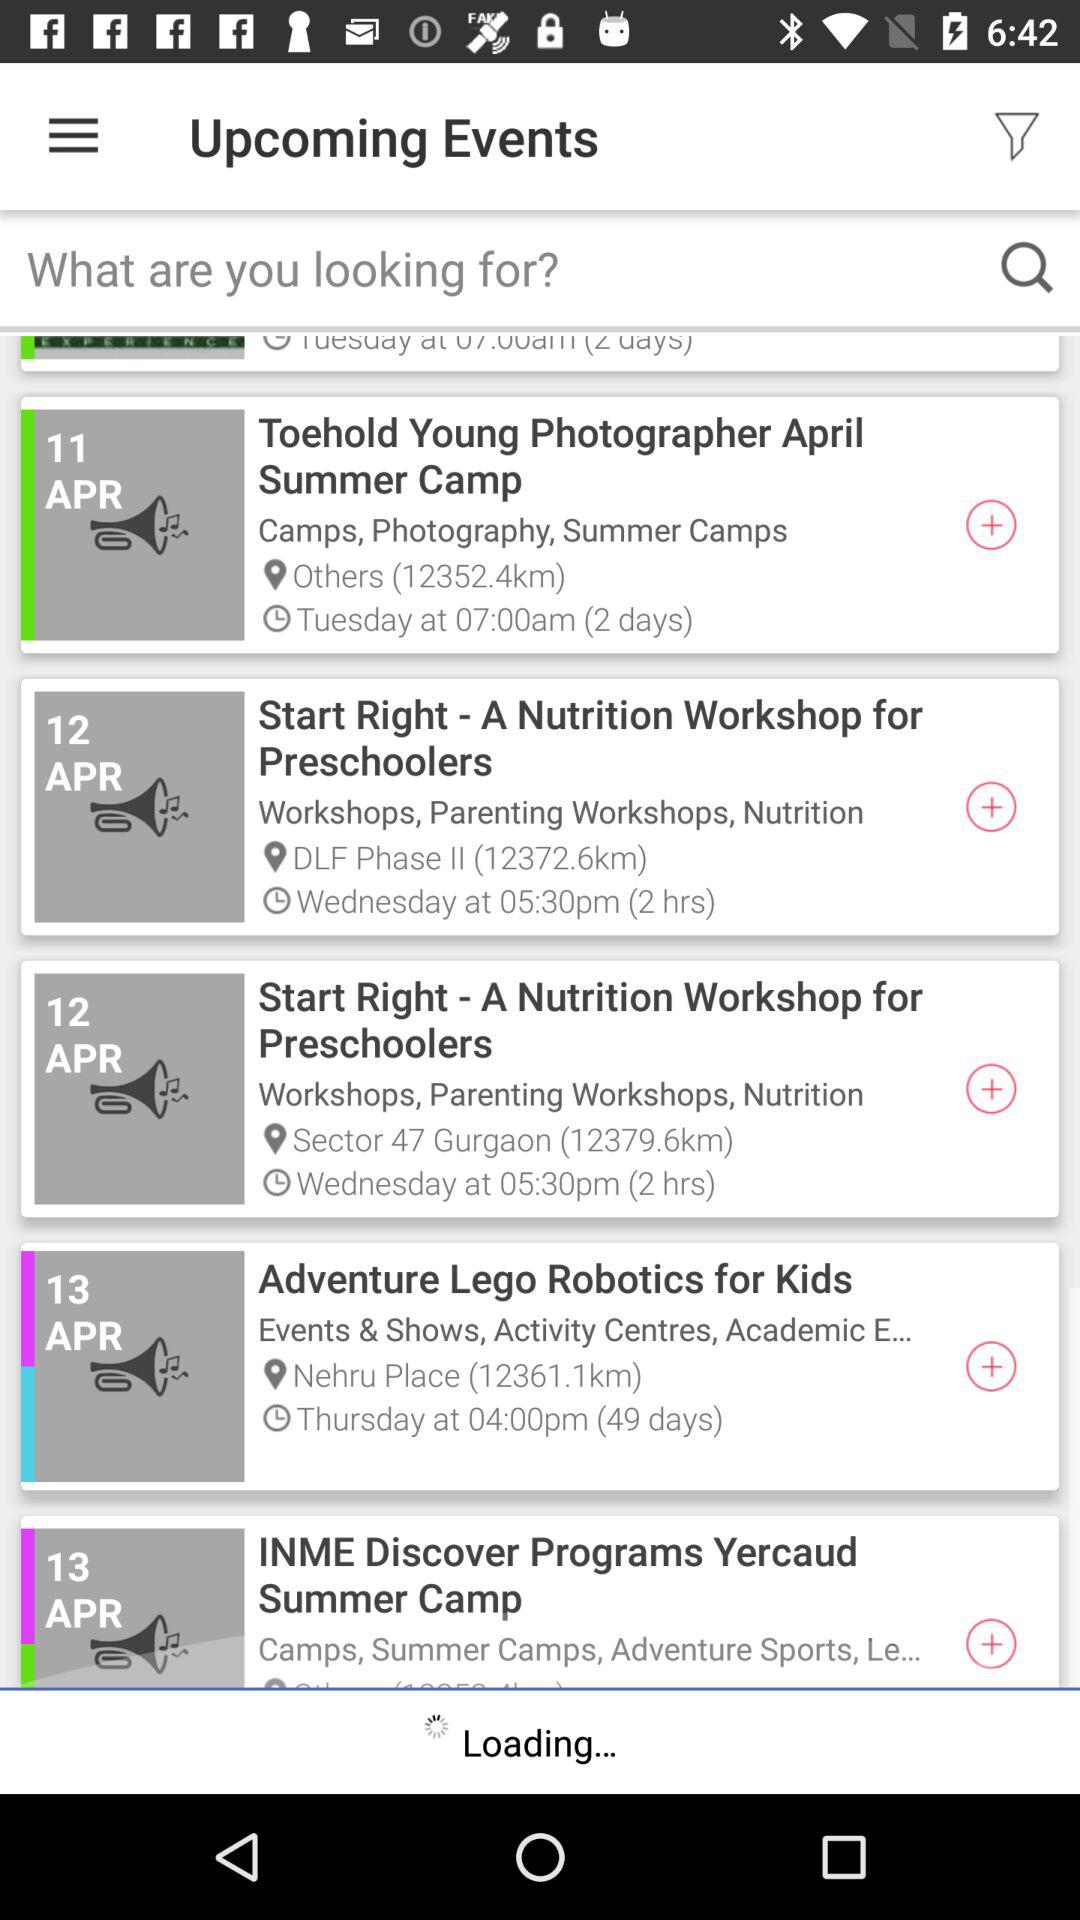On what date is the event "Toehold Young Photographer April Summer Camp" scheduled? It is scheduled for April 11. 